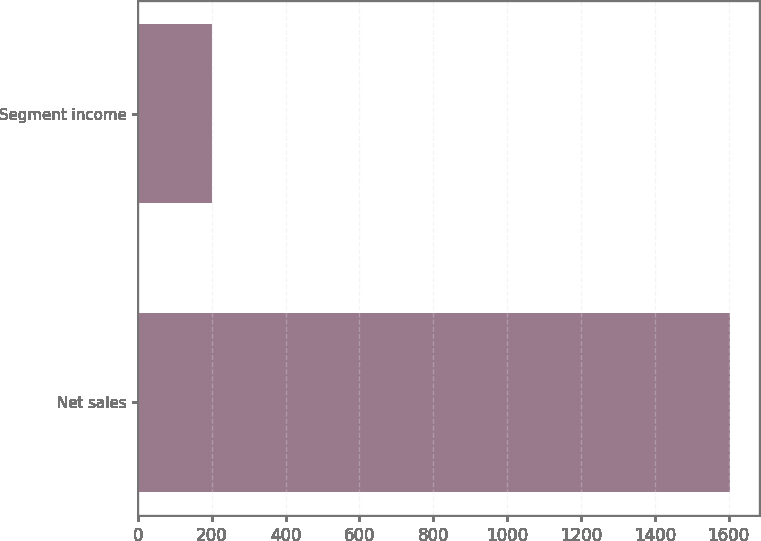Convert chart. <chart><loc_0><loc_0><loc_500><loc_500><bar_chart><fcel>Net sales<fcel>Segment income<nl><fcel>1603.1<fcel>201.3<nl></chart> 